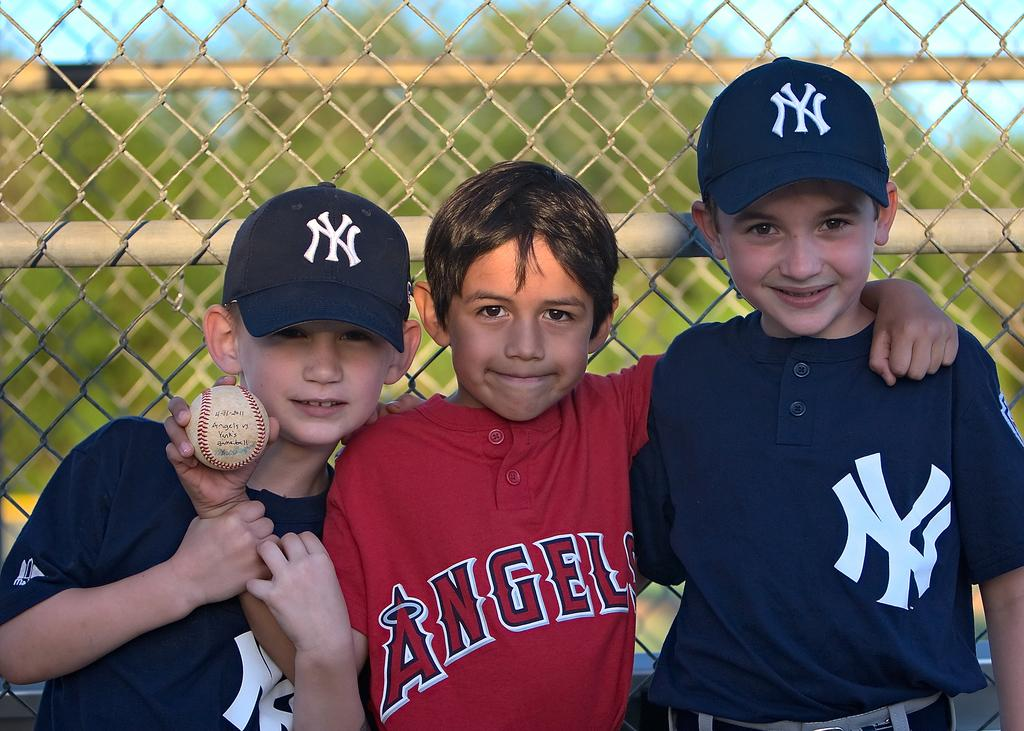<image>
Describe the image concisely. A boy wearing a red Angels shirt stands next to two boys wearing blue. 